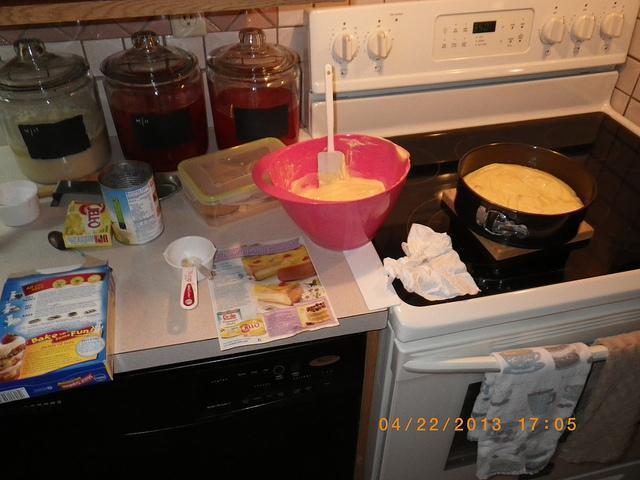How many jars are visible?
Give a very brief answer. 3. 